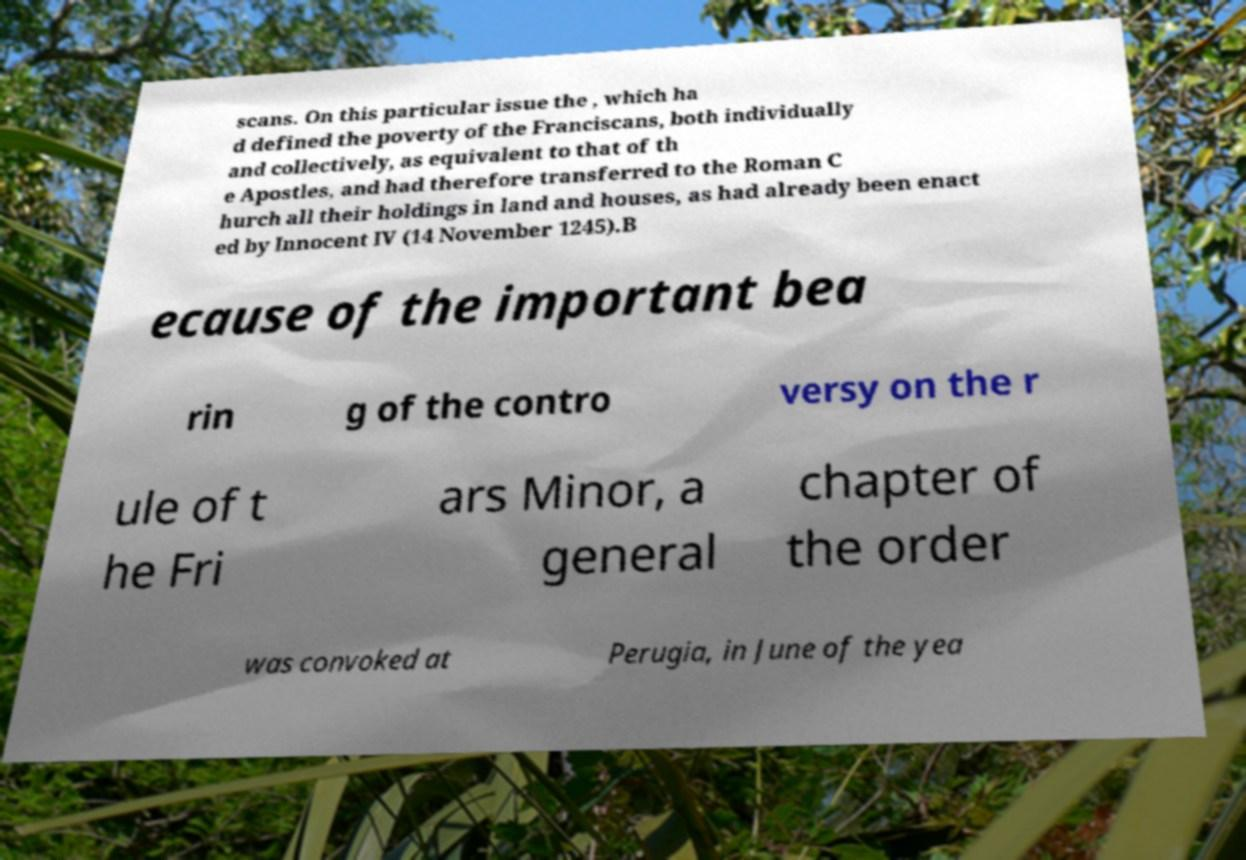Can you read and provide the text displayed in the image?This photo seems to have some interesting text. Can you extract and type it out for me? scans. On this particular issue the , which ha d defined the poverty of the Franciscans, both individually and collectively, as equivalent to that of th e Apostles, and had therefore transferred to the Roman C hurch all their holdings in land and houses, as had already been enact ed by Innocent IV (14 November 1245).B ecause of the important bea rin g of the contro versy on the r ule of t he Fri ars Minor, a general chapter of the order was convoked at Perugia, in June of the yea 